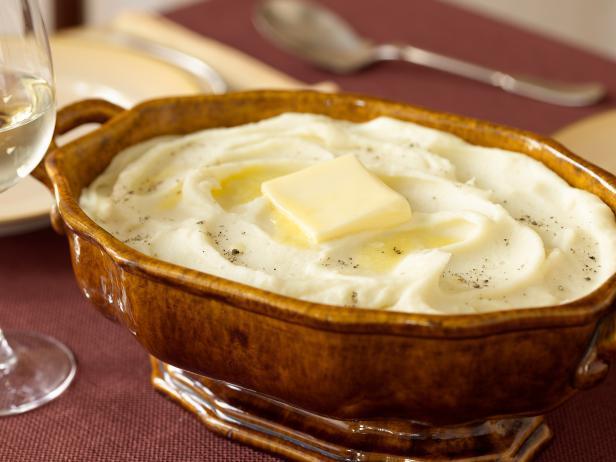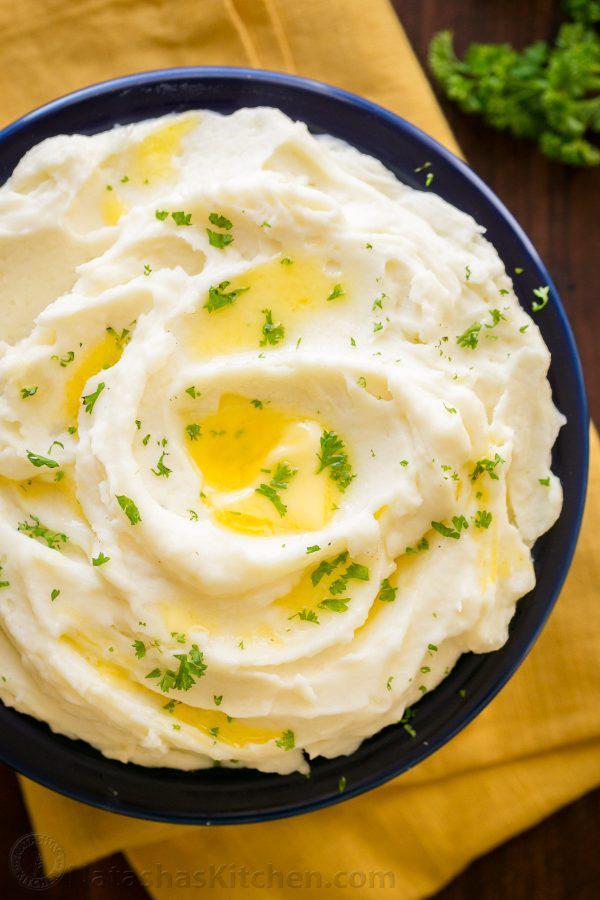The first image is the image on the left, the second image is the image on the right. Evaluate the accuracy of this statement regarding the images: "the bowl on the left image is all white". Is it true? Answer yes or no. No. The first image is the image on the left, the second image is the image on the right. Given the left and right images, does the statement "At least one bowl is white." hold true? Answer yes or no. No. The first image is the image on the left, the second image is the image on the right. For the images displayed, is the sentence "The dish on the right contains a large piece of green garnish." factually correct? Answer yes or no. No. The first image is the image on the left, the second image is the image on the right. For the images shown, is this caption "An image shows a bowl of mashed potatoes garnished with one green sprig." true? Answer yes or no. No. 